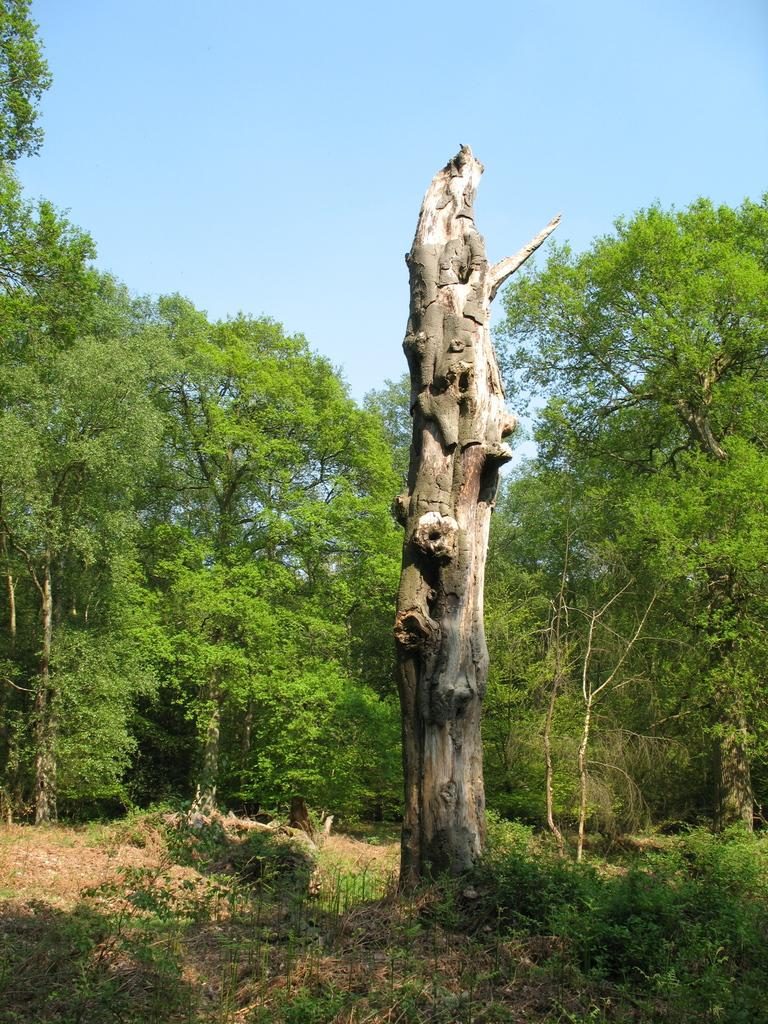What is the main object in the image? There is a dried branch in the image. Where is the branch located? The branch is in a forest area. What else can be seen in the image besides the branch? There are plants visible in the image. What is visible in the background of the image? There are trees and the sky visible in the background of the image. What type of paper is being used to cover the branch in the image? There is no paper present in the image, and the branch is not covered. Can you provide a suggestion for a new location to place the branch in the image? The image is a static representation, and no suggestions for changes can be made. 